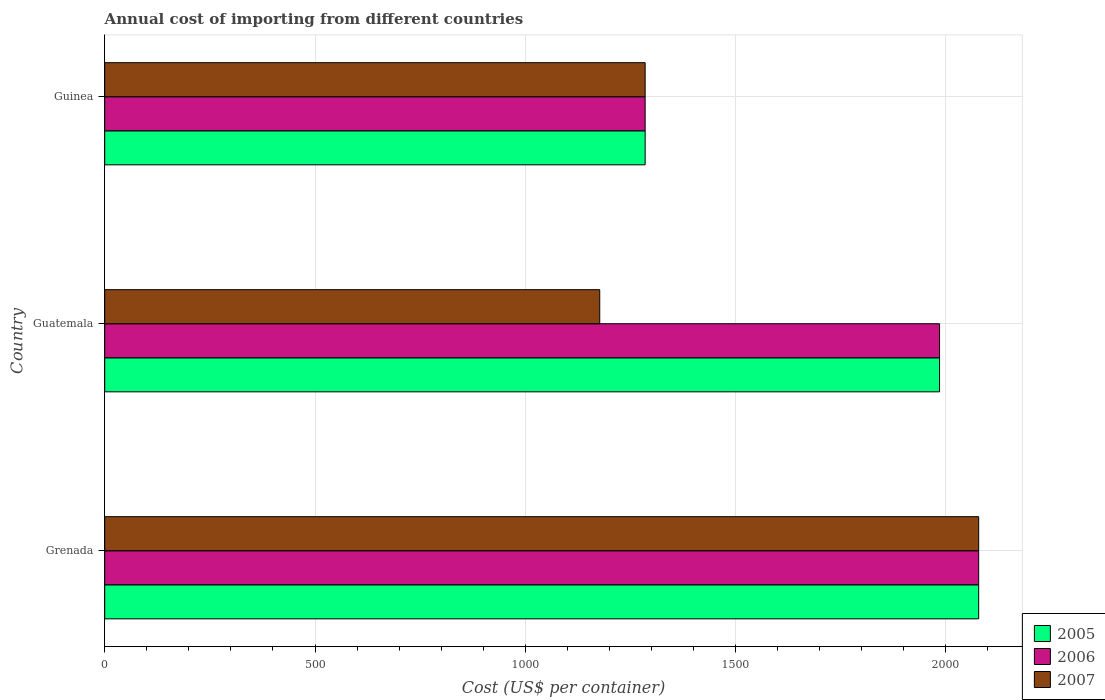How many different coloured bars are there?
Give a very brief answer. 3. How many groups of bars are there?
Your answer should be compact. 3. Are the number of bars on each tick of the Y-axis equal?
Offer a terse response. Yes. How many bars are there on the 2nd tick from the bottom?
Offer a terse response. 3. What is the label of the 1st group of bars from the top?
Provide a succinct answer. Guinea. What is the total annual cost of importing in 2005 in Guatemala?
Ensure brevity in your answer.  1985. Across all countries, what is the maximum total annual cost of importing in 2006?
Give a very brief answer. 2078. Across all countries, what is the minimum total annual cost of importing in 2006?
Make the answer very short. 1285. In which country was the total annual cost of importing in 2006 maximum?
Your answer should be very brief. Grenada. In which country was the total annual cost of importing in 2006 minimum?
Provide a succinct answer. Guinea. What is the total total annual cost of importing in 2005 in the graph?
Offer a very short reply. 5348. What is the difference between the total annual cost of importing in 2007 in Grenada and that in Guatemala?
Give a very brief answer. 901. What is the difference between the total annual cost of importing in 2005 in Guatemala and the total annual cost of importing in 2007 in Guinea?
Give a very brief answer. 700. What is the average total annual cost of importing in 2007 per country?
Keep it short and to the point. 1513.33. What is the difference between the total annual cost of importing in 2007 and total annual cost of importing in 2006 in Guatemala?
Your answer should be very brief. -808. In how many countries, is the total annual cost of importing in 2005 greater than 1000 US$?
Your answer should be compact. 3. What is the ratio of the total annual cost of importing in 2006 in Guatemala to that in Guinea?
Offer a terse response. 1.54. Is the total annual cost of importing in 2007 in Grenada less than that in Guinea?
Your response must be concise. No. Is the difference between the total annual cost of importing in 2007 in Guatemala and Guinea greater than the difference between the total annual cost of importing in 2006 in Guatemala and Guinea?
Provide a succinct answer. No. What is the difference between the highest and the second highest total annual cost of importing in 2006?
Offer a very short reply. 93. What is the difference between the highest and the lowest total annual cost of importing in 2007?
Keep it short and to the point. 901. In how many countries, is the total annual cost of importing in 2006 greater than the average total annual cost of importing in 2006 taken over all countries?
Give a very brief answer. 2. What does the 3rd bar from the top in Guinea represents?
Your answer should be compact. 2005. What does the 3rd bar from the bottom in Guatemala represents?
Your answer should be very brief. 2007. How many countries are there in the graph?
Your answer should be very brief. 3. Does the graph contain grids?
Offer a very short reply. Yes. How many legend labels are there?
Provide a succinct answer. 3. What is the title of the graph?
Give a very brief answer. Annual cost of importing from different countries. What is the label or title of the X-axis?
Offer a very short reply. Cost (US$ per container). What is the label or title of the Y-axis?
Ensure brevity in your answer.  Country. What is the Cost (US$ per container) of 2005 in Grenada?
Offer a very short reply. 2078. What is the Cost (US$ per container) of 2006 in Grenada?
Your response must be concise. 2078. What is the Cost (US$ per container) in 2007 in Grenada?
Offer a terse response. 2078. What is the Cost (US$ per container) in 2005 in Guatemala?
Provide a short and direct response. 1985. What is the Cost (US$ per container) in 2006 in Guatemala?
Make the answer very short. 1985. What is the Cost (US$ per container) of 2007 in Guatemala?
Keep it short and to the point. 1177. What is the Cost (US$ per container) of 2005 in Guinea?
Ensure brevity in your answer.  1285. What is the Cost (US$ per container) in 2006 in Guinea?
Make the answer very short. 1285. What is the Cost (US$ per container) of 2007 in Guinea?
Provide a short and direct response. 1285. Across all countries, what is the maximum Cost (US$ per container) in 2005?
Ensure brevity in your answer.  2078. Across all countries, what is the maximum Cost (US$ per container) in 2006?
Offer a terse response. 2078. Across all countries, what is the maximum Cost (US$ per container) in 2007?
Offer a very short reply. 2078. Across all countries, what is the minimum Cost (US$ per container) in 2005?
Give a very brief answer. 1285. Across all countries, what is the minimum Cost (US$ per container) in 2006?
Give a very brief answer. 1285. Across all countries, what is the minimum Cost (US$ per container) in 2007?
Offer a very short reply. 1177. What is the total Cost (US$ per container) of 2005 in the graph?
Offer a terse response. 5348. What is the total Cost (US$ per container) of 2006 in the graph?
Keep it short and to the point. 5348. What is the total Cost (US$ per container) of 2007 in the graph?
Provide a succinct answer. 4540. What is the difference between the Cost (US$ per container) in 2005 in Grenada and that in Guatemala?
Offer a very short reply. 93. What is the difference between the Cost (US$ per container) of 2006 in Grenada and that in Guatemala?
Your response must be concise. 93. What is the difference between the Cost (US$ per container) of 2007 in Grenada and that in Guatemala?
Give a very brief answer. 901. What is the difference between the Cost (US$ per container) of 2005 in Grenada and that in Guinea?
Provide a succinct answer. 793. What is the difference between the Cost (US$ per container) in 2006 in Grenada and that in Guinea?
Keep it short and to the point. 793. What is the difference between the Cost (US$ per container) of 2007 in Grenada and that in Guinea?
Keep it short and to the point. 793. What is the difference between the Cost (US$ per container) in 2005 in Guatemala and that in Guinea?
Give a very brief answer. 700. What is the difference between the Cost (US$ per container) of 2006 in Guatemala and that in Guinea?
Your answer should be compact. 700. What is the difference between the Cost (US$ per container) of 2007 in Guatemala and that in Guinea?
Your answer should be compact. -108. What is the difference between the Cost (US$ per container) of 2005 in Grenada and the Cost (US$ per container) of 2006 in Guatemala?
Your response must be concise. 93. What is the difference between the Cost (US$ per container) of 2005 in Grenada and the Cost (US$ per container) of 2007 in Guatemala?
Offer a very short reply. 901. What is the difference between the Cost (US$ per container) in 2006 in Grenada and the Cost (US$ per container) in 2007 in Guatemala?
Your answer should be very brief. 901. What is the difference between the Cost (US$ per container) in 2005 in Grenada and the Cost (US$ per container) in 2006 in Guinea?
Your answer should be very brief. 793. What is the difference between the Cost (US$ per container) in 2005 in Grenada and the Cost (US$ per container) in 2007 in Guinea?
Your answer should be compact. 793. What is the difference between the Cost (US$ per container) in 2006 in Grenada and the Cost (US$ per container) in 2007 in Guinea?
Give a very brief answer. 793. What is the difference between the Cost (US$ per container) of 2005 in Guatemala and the Cost (US$ per container) of 2006 in Guinea?
Provide a short and direct response. 700. What is the difference between the Cost (US$ per container) of 2005 in Guatemala and the Cost (US$ per container) of 2007 in Guinea?
Make the answer very short. 700. What is the difference between the Cost (US$ per container) in 2006 in Guatemala and the Cost (US$ per container) in 2007 in Guinea?
Provide a succinct answer. 700. What is the average Cost (US$ per container) of 2005 per country?
Give a very brief answer. 1782.67. What is the average Cost (US$ per container) in 2006 per country?
Offer a very short reply. 1782.67. What is the average Cost (US$ per container) in 2007 per country?
Your answer should be very brief. 1513.33. What is the difference between the Cost (US$ per container) of 2005 and Cost (US$ per container) of 2006 in Grenada?
Make the answer very short. 0. What is the difference between the Cost (US$ per container) of 2005 and Cost (US$ per container) of 2006 in Guatemala?
Give a very brief answer. 0. What is the difference between the Cost (US$ per container) in 2005 and Cost (US$ per container) in 2007 in Guatemala?
Your response must be concise. 808. What is the difference between the Cost (US$ per container) of 2006 and Cost (US$ per container) of 2007 in Guatemala?
Offer a very short reply. 808. What is the difference between the Cost (US$ per container) in 2005 and Cost (US$ per container) in 2006 in Guinea?
Give a very brief answer. 0. What is the ratio of the Cost (US$ per container) in 2005 in Grenada to that in Guatemala?
Provide a succinct answer. 1.05. What is the ratio of the Cost (US$ per container) of 2006 in Grenada to that in Guatemala?
Keep it short and to the point. 1.05. What is the ratio of the Cost (US$ per container) of 2007 in Grenada to that in Guatemala?
Your answer should be compact. 1.77. What is the ratio of the Cost (US$ per container) of 2005 in Grenada to that in Guinea?
Your answer should be very brief. 1.62. What is the ratio of the Cost (US$ per container) of 2006 in Grenada to that in Guinea?
Keep it short and to the point. 1.62. What is the ratio of the Cost (US$ per container) of 2007 in Grenada to that in Guinea?
Provide a succinct answer. 1.62. What is the ratio of the Cost (US$ per container) in 2005 in Guatemala to that in Guinea?
Your answer should be compact. 1.54. What is the ratio of the Cost (US$ per container) of 2006 in Guatemala to that in Guinea?
Ensure brevity in your answer.  1.54. What is the ratio of the Cost (US$ per container) of 2007 in Guatemala to that in Guinea?
Provide a short and direct response. 0.92. What is the difference between the highest and the second highest Cost (US$ per container) of 2005?
Keep it short and to the point. 93. What is the difference between the highest and the second highest Cost (US$ per container) of 2006?
Offer a terse response. 93. What is the difference between the highest and the second highest Cost (US$ per container) in 2007?
Provide a short and direct response. 793. What is the difference between the highest and the lowest Cost (US$ per container) of 2005?
Give a very brief answer. 793. What is the difference between the highest and the lowest Cost (US$ per container) in 2006?
Make the answer very short. 793. What is the difference between the highest and the lowest Cost (US$ per container) in 2007?
Offer a terse response. 901. 